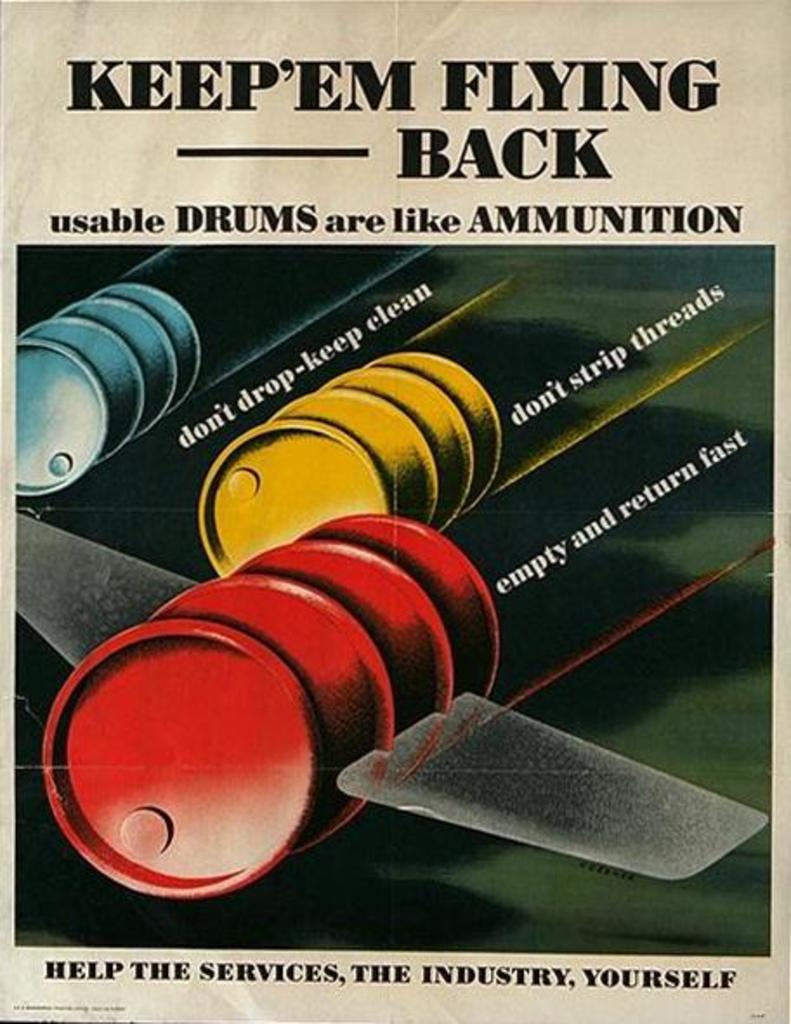Provide a one-sentence caption for the provided image. A flyer with oil barrels that have wings and says Keep`em Flying Back. 